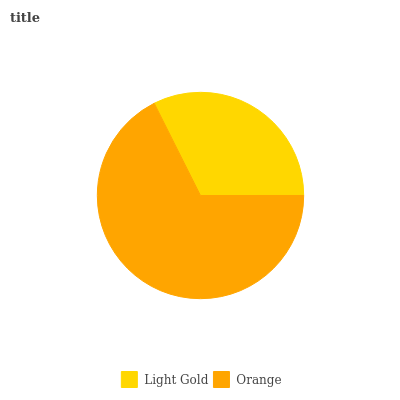Is Light Gold the minimum?
Answer yes or no. Yes. Is Orange the maximum?
Answer yes or no. Yes. Is Orange the minimum?
Answer yes or no. No. Is Orange greater than Light Gold?
Answer yes or no. Yes. Is Light Gold less than Orange?
Answer yes or no. Yes. Is Light Gold greater than Orange?
Answer yes or no. No. Is Orange less than Light Gold?
Answer yes or no. No. Is Orange the high median?
Answer yes or no. Yes. Is Light Gold the low median?
Answer yes or no. Yes. Is Light Gold the high median?
Answer yes or no. No. Is Orange the low median?
Answer yes or no. No. 